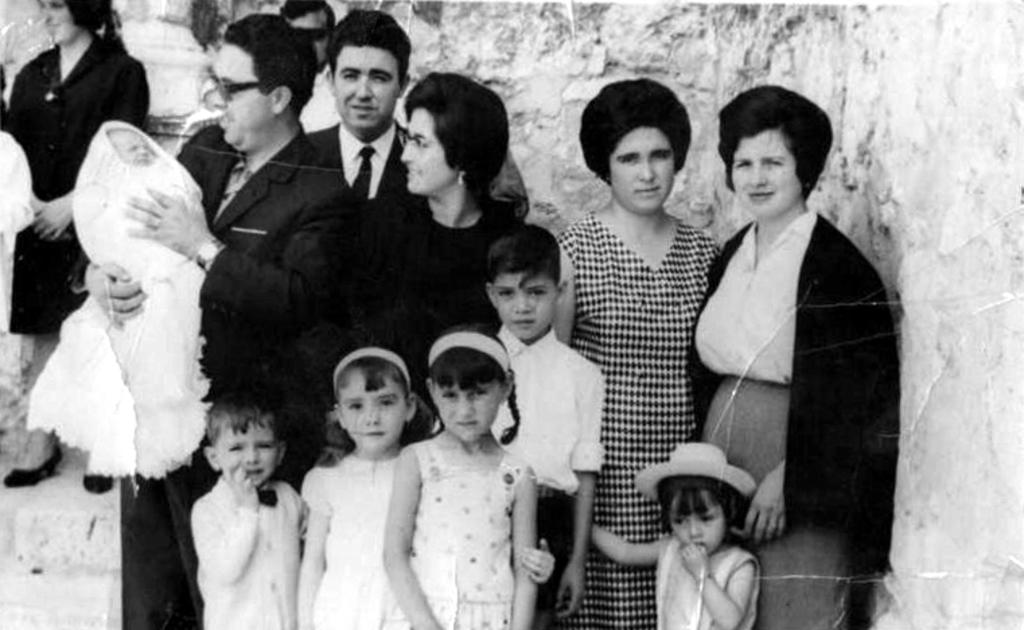What is the main subject of the image? There is a photo in the image. Who can be seen in the photo? There are men, women, kids, and a man holding a small baby in the photo. What is the background of the photo? There is a wall visible in the photo. What type of leg can be seen in the photo? There is no leg visible in the photo; it only shows people and a wall. What action is the stove performing in the photo? There is no stove present in the photo, so no action can be attributed to it. 